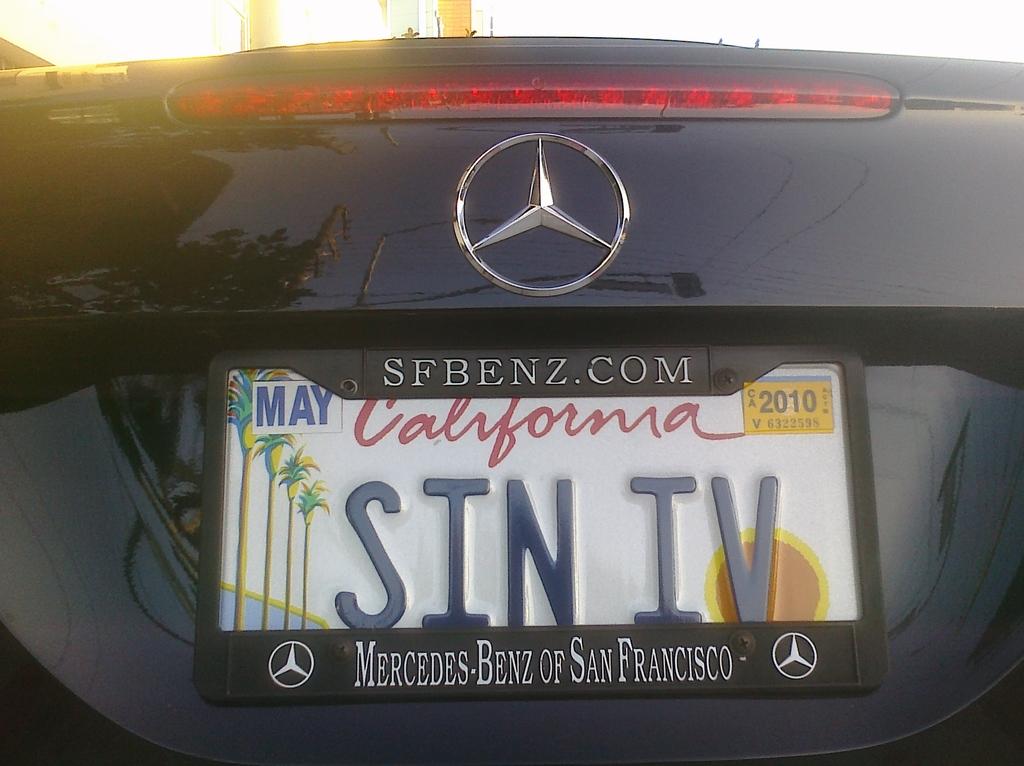What state license plate is this?
Ensure brevity in your answer.  California. What brand of car is this?
Provide a short and direct response. Mercedes benz. 